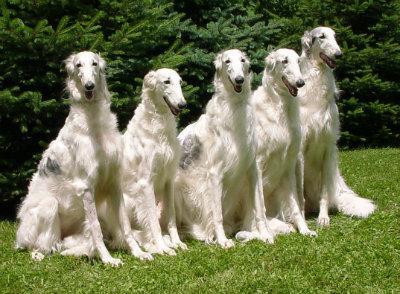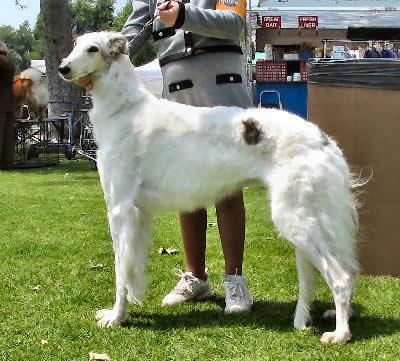The first image is the image on the left, the second image is the image on the right. Assess this claim about the two images: "There is one dog in one of the images, and four or more dogs in the other image.". Correct or not? Answer yes or no. Yes. The first image is the image on the left, the second image is the image on the right. Considering the images on both sides, is "A person is standing with the dog in the image on the right." valid? Answer yes or no. Yes. 